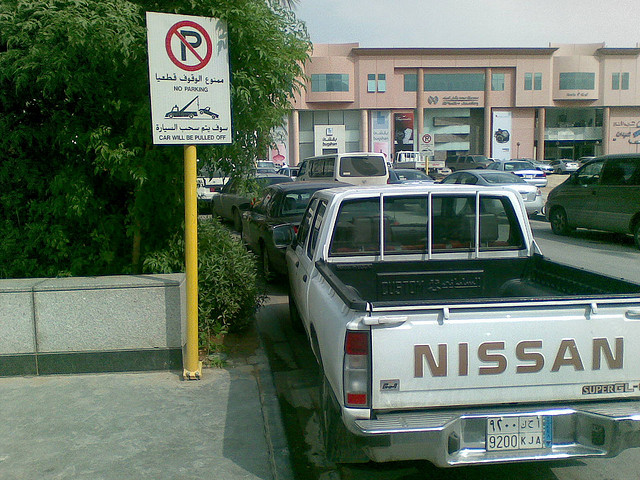What are the visible features of the vehicle in the foreground? The vehicle in the foreground is a Nissan pickup truck, with a prominent white color, featuring a cargo bed with a protective cover and a two-door cabin. 